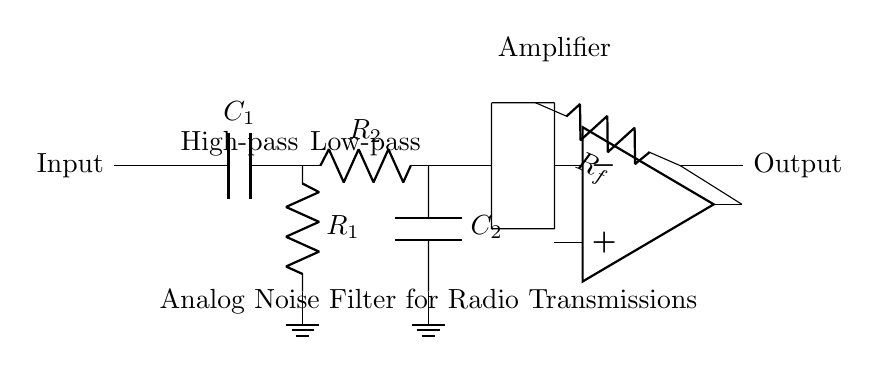What is the purpose of the capacitor labeled C1? The capacitor C1 is part of the high-pass filter, allowing high frequencies to pass while blocking low frequencies, which means it is used here to filter out unwanted low-frequency noise from the intercepted radio transmissions.
Answer: High-pass filter What type of amplifier is used in this circuit? The circuit utilizes an operational amplifier (op amp), commonly used in analog filter circuits for signal conditioning, amplification, and processing of the filtered output signal.
Answer: Operational amplifier What is the function of Rf in the circuit? The resistor Rf provides feedback to the op amp, adjusting the gain of the amplifier circuit and thus influencing how much the filtered signal is amplified before reaching the output.
Answer: Feedback resistor What kind of filter does R2 and C2 form together? R2 and C2 together form a low-pass filter, which allows signals with a frequency lower than a certain cutoff frequency to pass while attenuating higher frequencies.
Answer: Low-pass filter How many filtering stages are in this circuit? There are two filtering stages: a high-pass filter stage followed by a low-pass filter stage, which together help in removing noise from the radio transmission before amplification.
Answer: Two stages What is the input of this circuit? The input is the intercepted radio transmission signal, which typically contains both the desired signal and unwanted noise, requiring filtering for clarity and intelligibility.
Answer: Intercepted radio transmission 